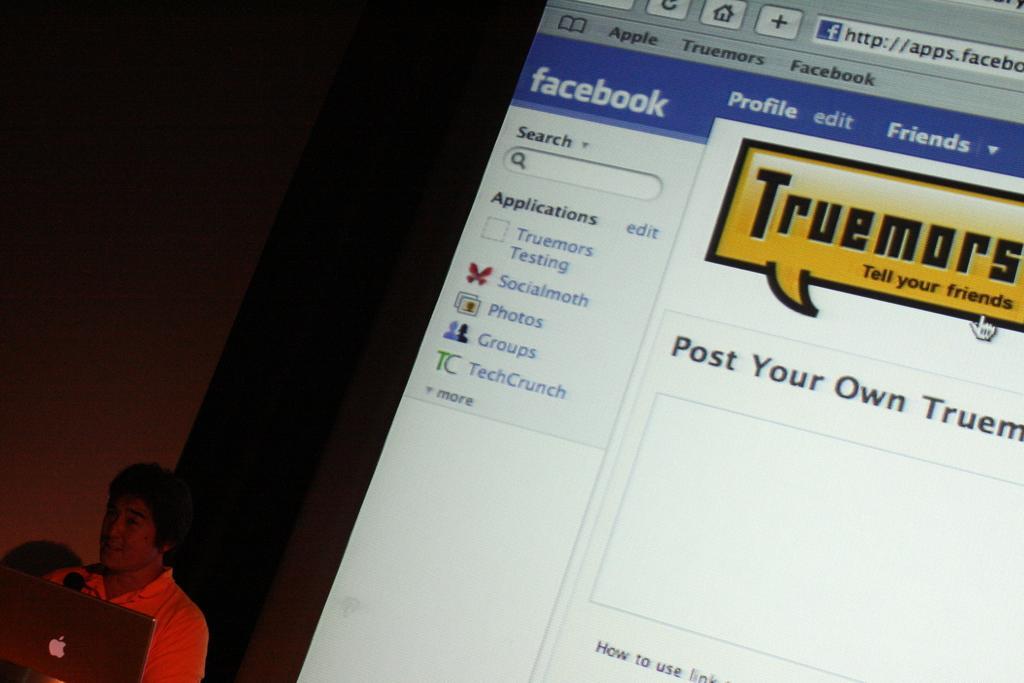How would you summarize this image in a sentence or two? In the bottom left corner of the image there is a laptop. Behind the laptop there is a man. Behind the man there is a screen with facebook page. 